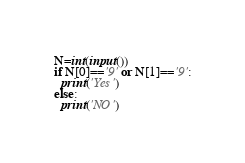Convert code to text. <code><loc_0><loc_0><loc_500><loc_500><_Python_>N=int(input())
if N[0]=='9' or N[1]=='9':
  print('Yes')
else:
  print('NO')</code> 